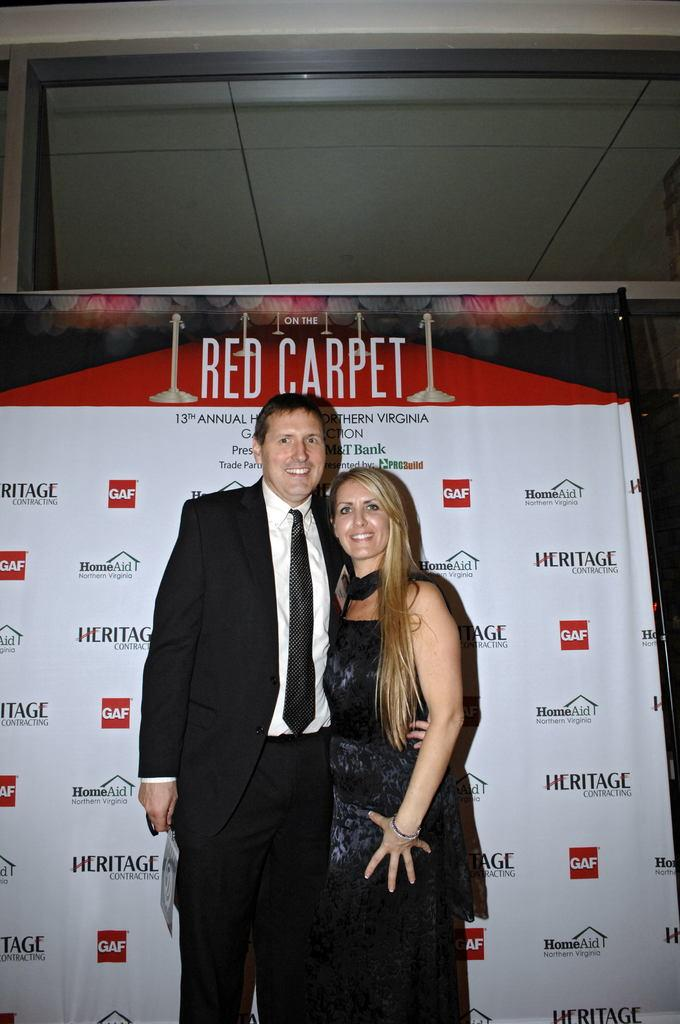How many people are present in the image? There are two people standing in the image. What can be seen on the board in the image? There is a written text on a board in the image. What object is located near the board in the image? There is a glass object near the board in the image. Can you hear the stranger crying in the image? There is no stranger or crying present in the image; it only shows two people and a board with written text. 